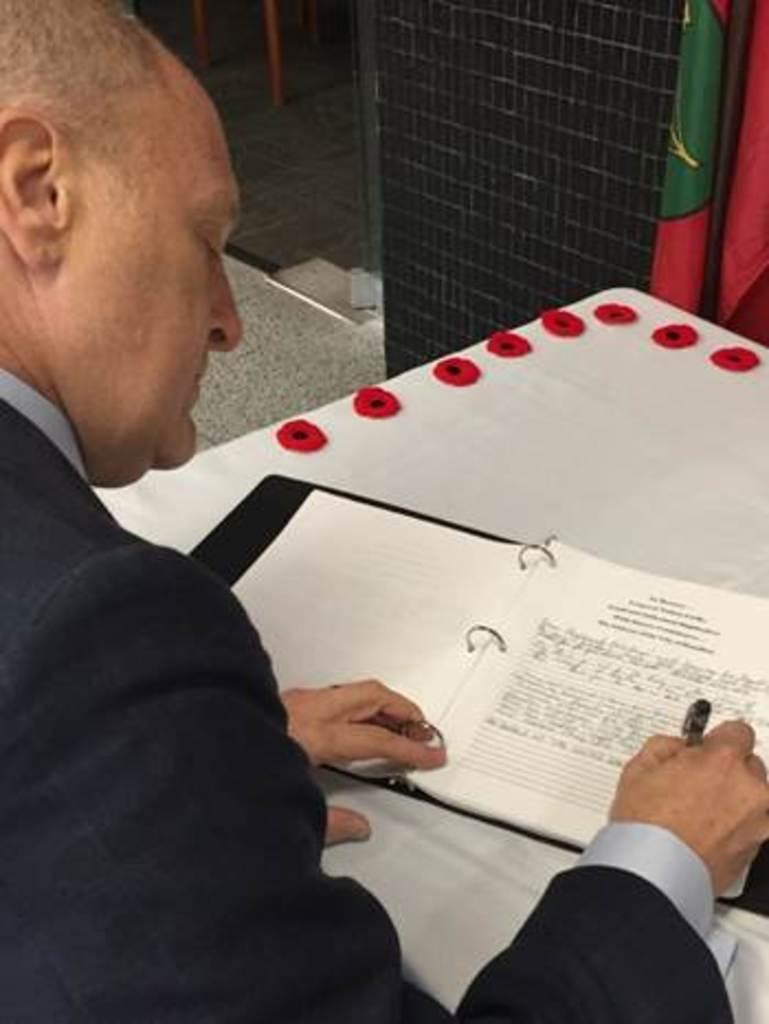Can you describe this image briefly? In this image, there is a person wearing clothes and writing something on a book which is on the table. 